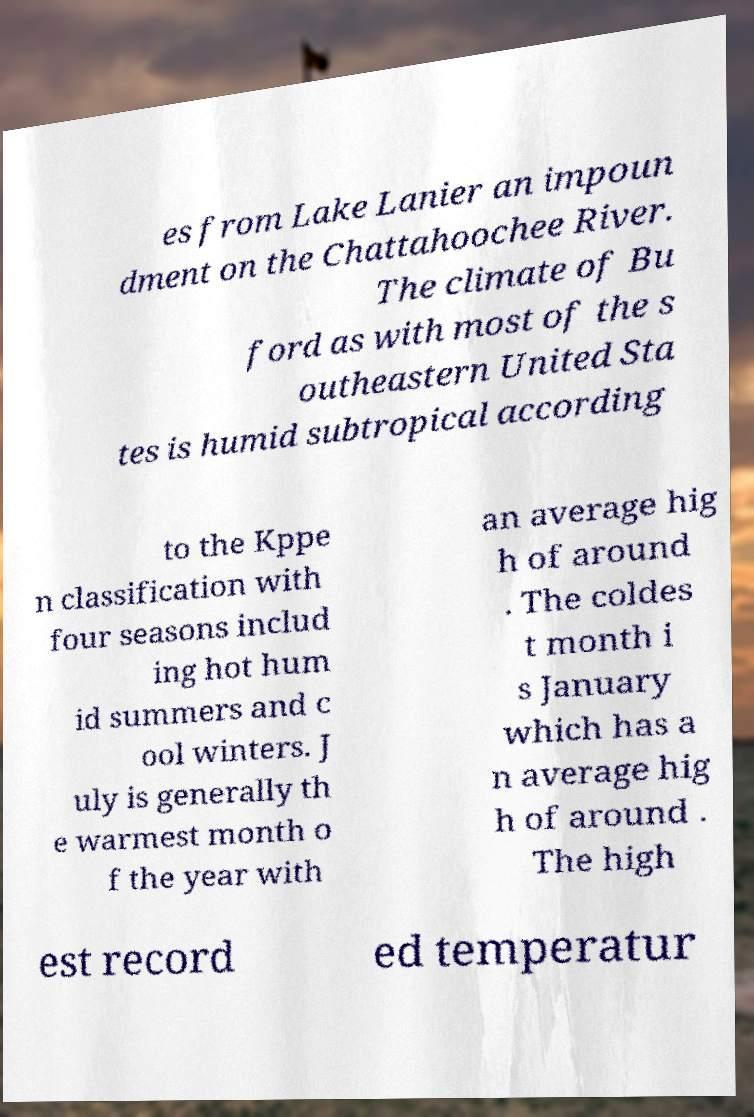Can you accurately transcribe the text from the provided image for me? es from Lake Lanier an impoun dment on the Chattahoochee River. The climate of Bu ford as with most of the s outheastern United Sta tes is humid subtropical according to the Kppe n classification with four seasons includ ing hot hum id summers and c ool winters. J uly is generally th e warmest month o f the year with an average hig h of around . The coldes t month i s January which has a n average hig h of around . The high est record ed temperatur 